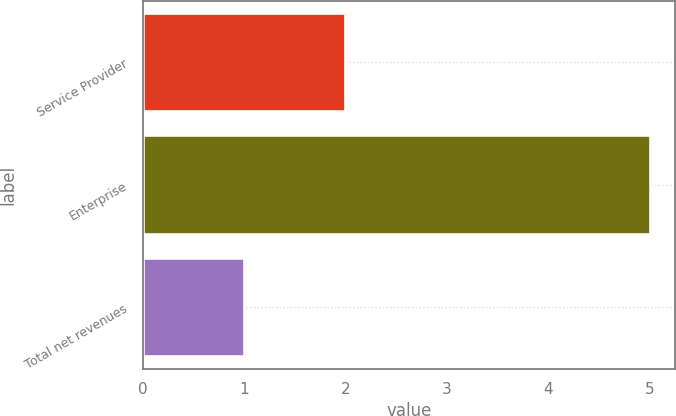<chart> <loc_0><loc_0><loc_500><loc_500><bar_chart><fcel>Service Provider<fcel>Enterprise<fcel>Total net revenues<nl><fcel>2<fcel>5<fcel>1<nl></chart> 